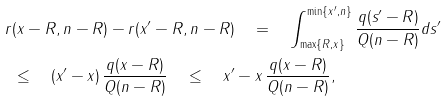<formula> <loc_0><loc_0><loc_500><loc_500>r & ( \| x \| - R , n - R ) - r ( \| x ^ { \prime } \| - R , n - R ) \quad = \quad \int _ { \max \{ R , \| x \| \} } ^ { \min \{ \| x ^ { \prime } \| , n \} } \frac { q ( s ^ { \prime } - R ) } { Q ( n - R ) } d s ^ { \prime } \\ & \leq \quad ( \| x ^ { \prime } \| - \| x \| ) \, \frac { q ( \| x \| - R ) } { Q ( n - R ) } \quad \leq \quad \| x ^ { \prime } - x \| \, \frac { q ( \| x \| - R ) } { Q ( n - R ) } ,</formula> 